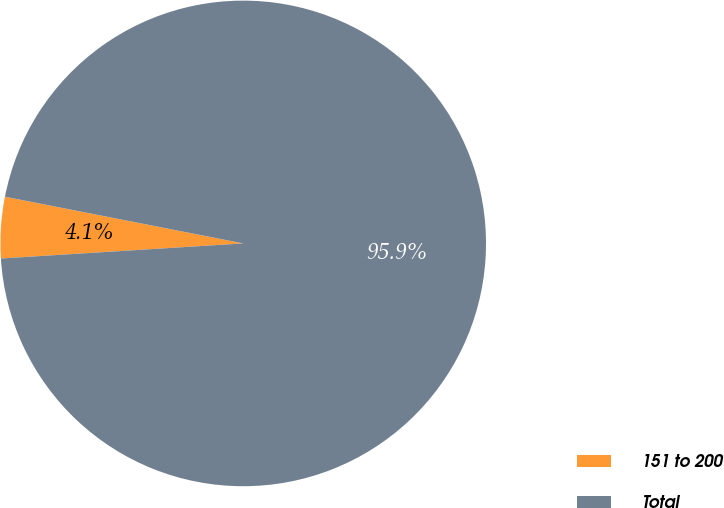Convert chart to OTSL. <chart><loc_0><loc_0><loc_500><loc_500><pie_chart><fcel>151 to 200<fcel>Total<nl><fcel>4.07%<fcel>95.93%<nl></chart> 